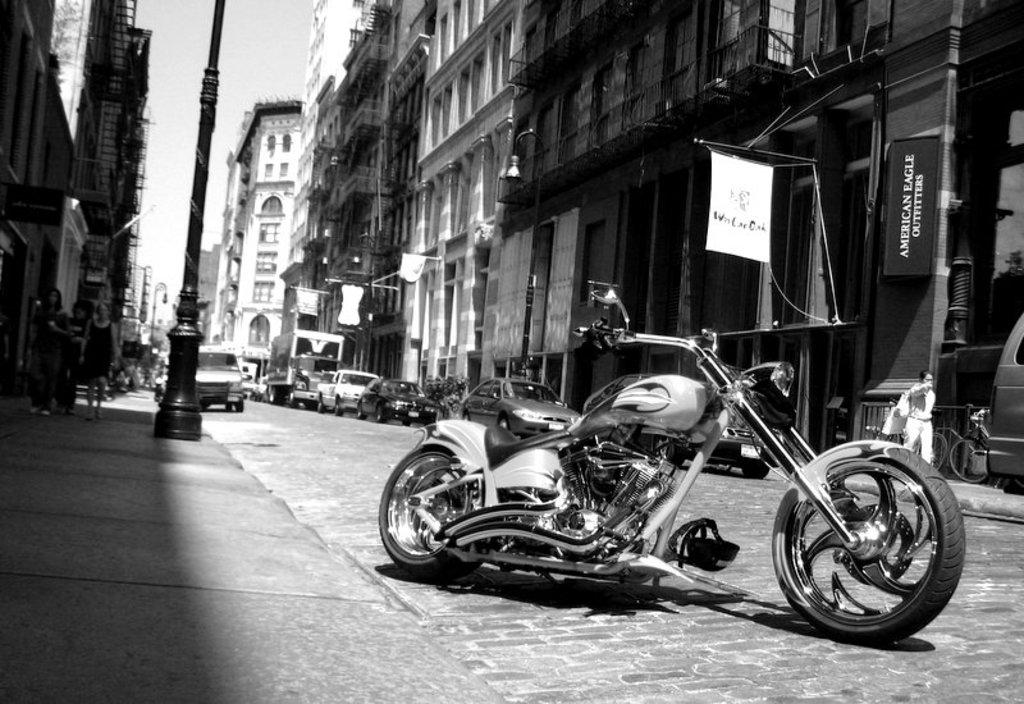What can be seen on the road in the image? There are vehicles on the road in the image. What is present on both sides of the road in the image? There are poles, buildings, banners, and pavements on both sides of the road in the image. What are people doing on the pavement in the image? People are walking on the pavement in the image. Can you tell me how many geese are flying over the buildings in the image? There are no geese present in the image; it only features vehicles, poles, buildings, banners, pavements, and people walking. 